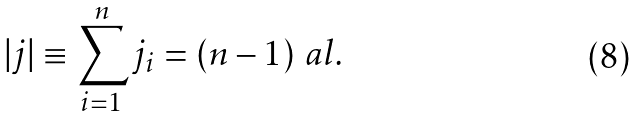<formula> <loc_0><loc_0><loc_500><loc_500>| j | \equiv \sum _ { i = 1 } ^ { n } j _ { i } = ( n - 1 ) \ a l .</formula> 